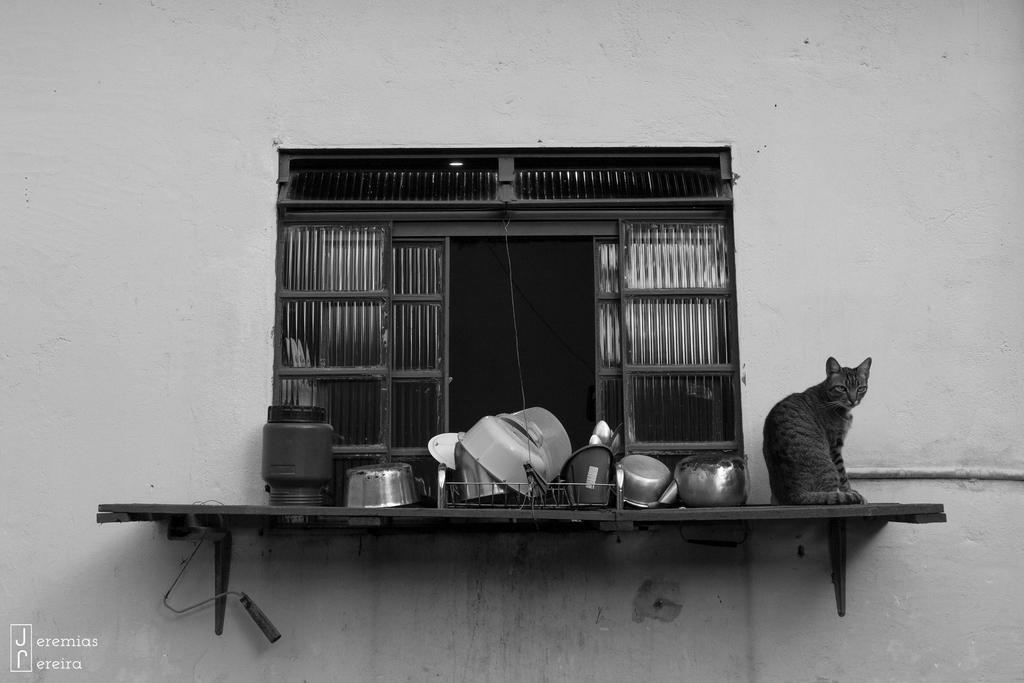Can you describe this image briefly? In the center of this picture we can see a rack attached to the wall and we can see a cat sitting on the rack and we can see the utensils placed on the rack. In the background we can see the wall and we can see an object attached to the wall. In the bottom left corner we can see the text on the image. 